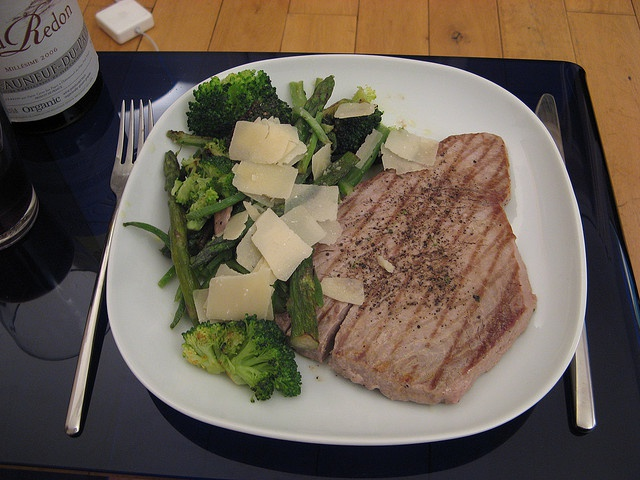Describe the objects in this image and their specific colors. I can see dining table in black, gray, darkgray, and tan tones, bottle in gray and black tones, cup in gray and black tones, broccoli in gray, darkgreen, black, and olive tones, and broccoli in gray, black, and darkgreen tones in this image. 